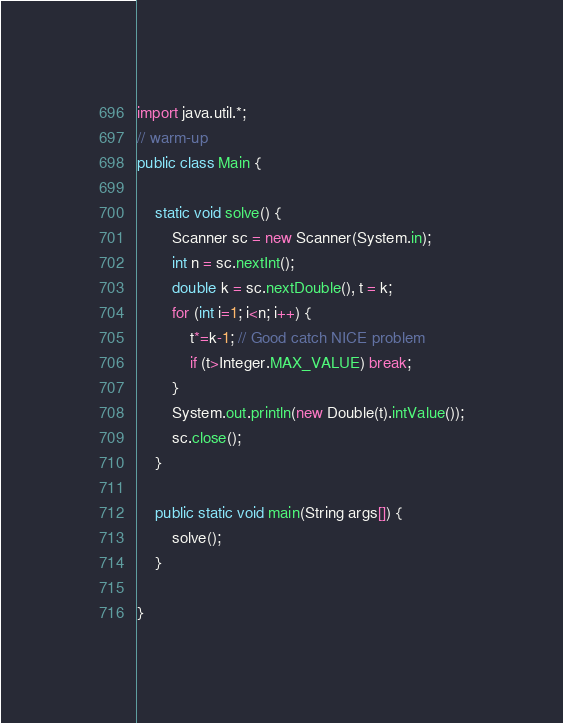<code> <loc_0><loc_0><loc_500><loc_500><_Java_>import java.util.*;
// warm-up
public class Main {

	static void solve() {
		Scanner sc = new Scanner(System.in);
		int n = sc.nextInt();
		double k = sc.nextDouble(), t = k;
		for (int i=1; i<n; i++) {
			t*=k-1; // Good catch NICE problem
			if (t>Integer.MAX_VALUE) break;
		}
		System.out.println(new Double(t).intValue());
		sc.close();			
	}

	public static void main(String args[]) {
		solve();
	}

}</code> 